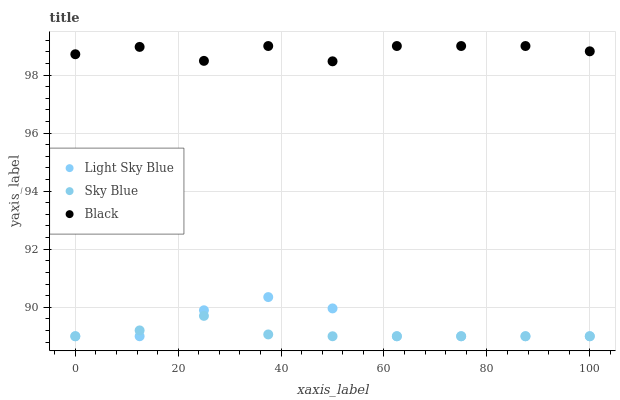Does Sky Blue have the minimum area under the curve?
Answer yes or no. Yes. Does Black have the maximum area under the curve?
Answer yes or no. Yes. Does Light Sky Blue have the minimum area under the curve?
Answer yes or no. No. Does Light Sky Blue have the maximum area under the curve?
Answer yes or no. No. Is Sky Blue the smoothest?
Answer yes or no. Yes. Is Black the roughest?
Answer yes or no. Yes. Is Light Sky Blue the smoothest?
Answer yes or no. No. Is Light Sky Blue the roughest?
Answer yes or no. No. Does Sky Blue have the lowest value?
Answer yes or no. Yes. Does Black have the lowest value?
Answer yes or no. No. Does Black have the highest value?
Answer yes or no. Yes. Does Light Sky Blue have the highest value?
Answer yes or no. No. Is Light Sky Blue less than Black?
Answer yes or no. Yes. Is Black greater than Light Sky Blue?
Answer yes or no. Yes. Does Sky Blue intersect Light Sky Blue?
Answer yes or no. Yes. Is Sky Blue less than Light Sky Blue?
Answer yes or no. No. Is Sky Blue greater than Light Sky Blue?
Answer yes or no. No. Does Light Sky Blue intersect Black?
Answer yes or no. No. 